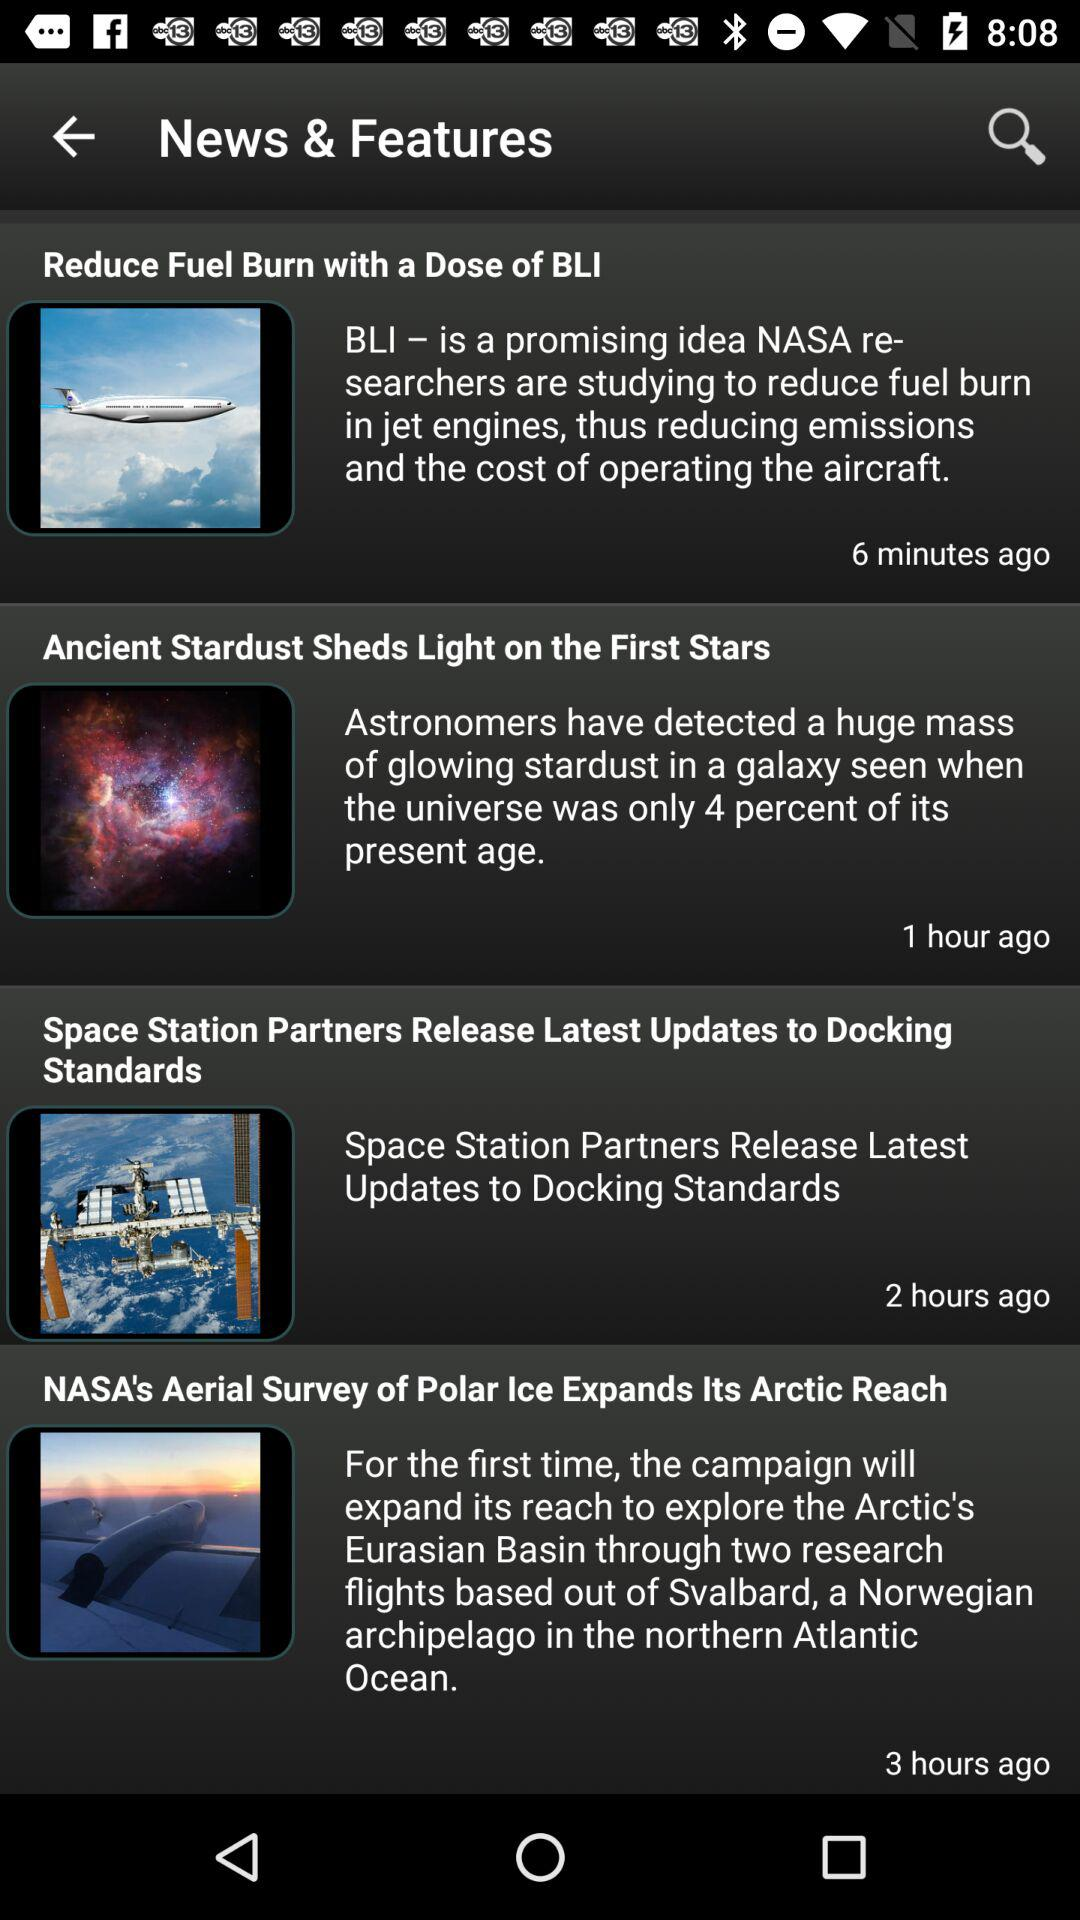Which news was posted 1 hour ago? The news that was posted 1 hour ago is "Ancient Stardust Sheds Light on the First Stars". 